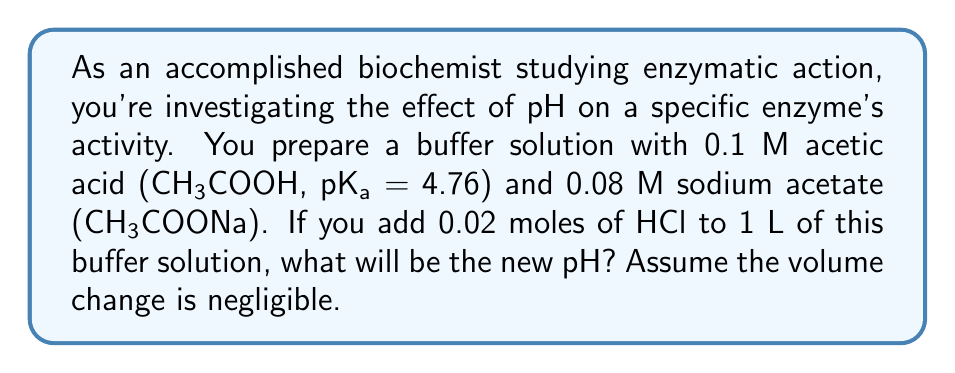What is the answer to this math problem? Let's approach this step-by-step:

1) First, we need to calculate the initial pH of the buffer solution using the Henderson-Hasselbalch equation:

   $$ pH = pKa + \log\frac{[A^-]}{[HA]} $$

   Where [A⁻] is the concentration of the conjugate base (acetate) and [HA] is the concentration of the weak acid (acetic acid).

2) Initial concentrations:
   [HA] = 0.1 M
   [A⁻] = 0.08 M

3) Plugging into the equation:

   $$ pH = 4.76 + \log\frac{0.08}{0.1} = 4.76 - 0.097 = 4.663 $$

4) When HCl is added, it reacts with the acetate ion to form acetic acid:

   CH₃COO⁻ + H⁺ → CH₃COOH

5) 0.02 moles of HCl will react with 0.02 moles of acetate, changing the concentrations:

   New [HA] = 0.1 + 0.02 = 0.12 M
   New [A⁻] = 0.08 - 0.02 = 0.06 M

6) Now we can calculate the new pH:

   $$ pH = 4.76 + \log\frac{0.06}{0.12} = 4.76 - 0.301 = 4.459 $$

Therefore, the new pH of the buffer solution after adding HCl is 4.459.
Answer: 4.459 